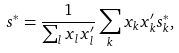Convert formula to latex. <formula><loc_0><loc_0><loc_500><loc_500>s ^ { * } = \frac { 1 } { \sum _ { l } x _ { l } x _ { l } ^ { \prime } } \sum _ { k } x _ { k } x _ { k } ^ { \prime } s _ { k } ^ { * } ,</formula> 